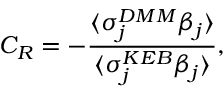Convert formula to latex. <formula><loc_0><loc_0><loc_500><loc_500>C _ { R } = - \frac { \langle \sigma _ { j } ^ { D M M } \beta _ { j } \rangle } { \langle \sigma _ { j } ^ { K E B } \beta _ { j } \rangle } ,</formula> 